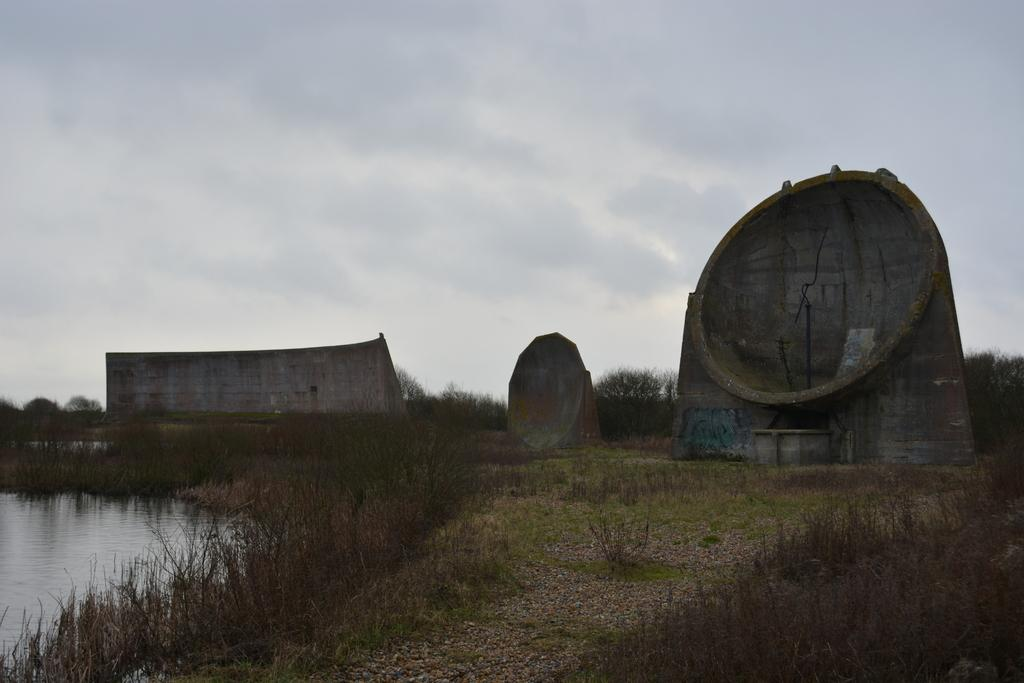What objects are placed on the ground in the image? There are rocks placed on the ground in the image. What type of vegetation can be seen in the background of the image? There is grass visible in the background of the image. What natural element is visible in the background of the image? There is water visible in the background of the image. What is visible at the top of the image? The sky is visible at the top of the image. What type of lettuce is being used as a pet in the image? There is no lettuce or pet present in the image. 